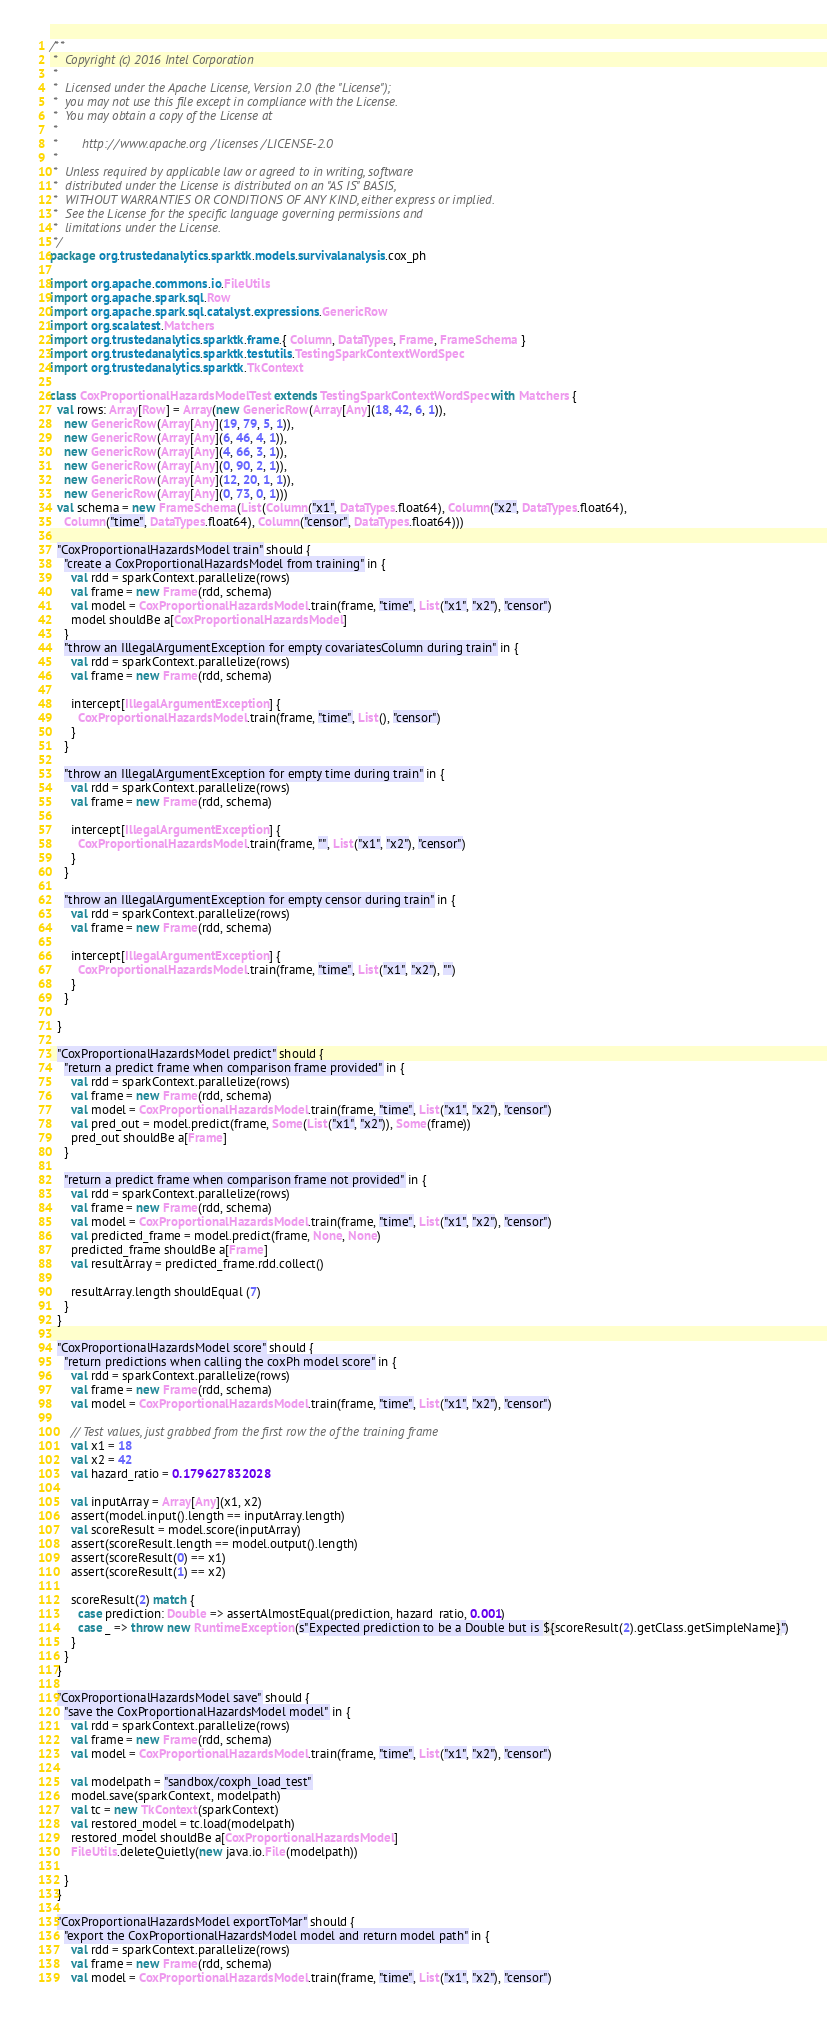Convert code to text. <code><loc_0><loc_0><loc_500><loc_500><_Scala_>/**
 *  Copyright (c) 2016 Intel Corporation 
 *
 *  Licensed under the Apache License, Version 2.0 (the "License");
 *  you may not use this file except in compliance with the License.
 *  You may obtain a copy of the License at
 *
 *       http://www.apache.org/licenses/LICENSE-2.0
 *
 *  Unless required by applicable law or agreed to in writing, software
 *  distributed under the License is distributed on an "AS IS" BASIS,
 *  WITHOUT WARRANTIES OR CONDITIONS OF ANY KIND, either express or implied.
 *  See the License for the specific language governing permissions and
 *  limitations under the License.
 */
package org.trustedanalytics.sparktk.models.survivalanalysis.cox_ph

import org.apache.commons.io.FileUtils
import org.apache.spark.sql.Row
import org.apache.spark.sql.catalyst.expressions.GenericRow
import org.scalatest.Matchers
import org.trustedanalytics.sparktk.frame.{ Column, DataTypes, Frame, FrameSchema }
import org.trustedanalytics.sparktk.testutils.TestingSparkContextWordSpec
import org.trustedanalytics.sparktk.TkContext

class CoxProportionalHazardsModelTest extends TestingSparkContextWordSpec with Matchers {
  val rows: Array[Row] = Array(new GenericRow(Array[Any](18, 42, 6, 1)),
    new GenericRow(Array[Any](19, 79, 5, 1)),
    new GenericRow(Array[Any](6, 46, 4, 1)),
    new GenericRow(Array[Any](4, 66, 3, 1)),
    new GenericRow(Array[Any](0, 90, 2, 1)),
    new GenericRow(Array[Any](12, 20, 1, 1)),
    new GenericRow(Array[Any](0, 73, 0, 1)))
  val schema = new FrameSchema(List(Column("x1", DataTypes.float64), Column("x2", DataTypes.float64),
    Column("time", DataTypes.float64), Column("censor", DataTypes.float64)))

  "CoxProportionalHazardsModel train" should {
    "create a CoxProportionalHazardsModel from training" in {
      val rdd = sparkContext.parallelize(rows)
      val frame = new Frame(rdd, schema)
      val model = CoxProportionalHazardsModel.train(frame, "time", List("x1", "x2"), "censor")
      model shouldBe a[CoxProportionalHazardsModel]
    }
    "throw an IllegalArgumentException for empty covariatesColumn during train" in {
      val rdd = sparkContext.parallelize(rows)
      val frame = new Frame(rdd, schema)

      intercept[IllegalArgumentException] {
        CoxProportionalHazardsModel.train(frame, "time", List(), "censor")
      }
    }

    "throw an IllegalArgumentException for empty time during train" in {
      val rdd = sparkContext.parallelize(rows)
      val frame = new Frame(rdd, schema)

      intercept[IllegalArgumentException] {
        CoxProportionalHazardsModel.train(frame, "", List("x1", "x2"), "censor")
      }
    }

    "throw an IllegalArgumentException for empty censor during train" in {
      val rdd = sparkContext.parallelize(rows)
      val frame = new Frame(rdd, schema)

      intercept[IllegalArgumentException] {
        CoxProportionalHazardsModel.train(frame, "time", List("x1", "x2"), "")
      }
    }

  }

  "CoxProportionalHazardsModel predict" should {
    "return a predict frame when comparison frame provided" in {
      val rdd = sparkContext.parallelize(rows)
      val frame = new Frame(rdd, schema)
      val model = CoxProportionalHazardsModel.train(frame, "time", List("x1", "x2"), "censor")
      val pred_out = model.predict(frame, Some(List("x1", "x2")), Some(frame))
      pred_out shouldBe a[Frame]
    }

    "return a predict frame when comparison frame not provided" in {
      val rdd = sparkContext.parallelize(rows)
      val frame = new Frame(rdd, schema)
      val model = CoxProportionalHazardsModel.train(frame, "time", List("x1", "x2"), "censor")
      val predicted_frame = model.predict(frame, None, None)
      predicted_frame shouldBe a[Frame]
      val resultArray = predicted_frame.rdd.collect()

      resultArray.length shouldEqual (7)
    }
  }

  "CoxProportionalHazardsModel score" should {
    "return predictions when calling the coxPh model score" in {
      val rdd = sparkContext.parallelize(rows)
      val frame = new Frame(rdd, schema)
      val model = CoxProportionalHazardsModel.train(frame, "time", List("x1", "x2"), "censor")

      // Test values, just grabbed from the first row the of the training frame
      val x1 = 18
      val x2 = 42
      val hazard_ratio = 0.179627832028

      val inputArray = Array[Any](x1, x2)
      assert(model.input().length == inputArray.length)
      val scoreResult = model.score(inputArray)
      assert(scoreResult.length == model.output().length)
      assert(scoreResult(0) == x1)
      assert(scoreResult(1) == x2)

      scoreResult(2) match {
        case prediction: Double => assertAlmostEqual(prediction, hazard_ratio, 0.001)
        case _ => throw new RuntimeException(s"Expected prediction to be a Double but is ${scoreResult(2).getClass.getSimpleName}")
      }
    }
  }

  "CoxProportionalHazardsModel save" should {
    "save the CoxProportionalHazardsModel model" in {
      val rdd = sparkContext.parallelize(rows)
      val frame = new Frame(rdd, schema)
      val model = CoxProportionalHazardsModel.train(frame, "time", List("x1", "x2"), "censor")

      val modelpath = "sandbox/coxph_load_test"
      model.save(sparkContext, modelpath)
      val tc = new TkContext(sparkContext)
      val restored_model = tc.load(modelpath)
      restored_model shouldBe a[CoxProportionalHazardsModel]
      FileUtils.deleteQuietly(new java.io.File(modelpath))

    }
  }

  "CoxProportionalHazardsModel exportToMar" should {
    "export the CoxProportionalHazardsModel model and return model path" in {
      val rdd = sparkContext.parallelize(rows)
      val frame = new Frame(rdd, schema)
      val model = CoxProportionalHazardsModel.train(frame, "time", List("x1", "x2"), "censor")
</code> 